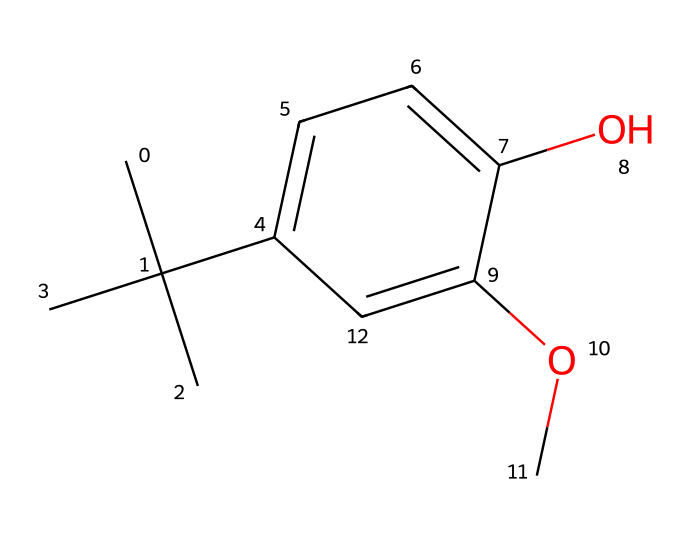What is the total number of carbon atoms in BHA? In the provided SMILES representation, count the 'C' symbols which correspond to carbon atoms. The chemical consists of a branched alkyl group (three carbon atoms) and a phenolic group (six carbon atoms), totaling nine carbon atoms.
Answer: nine How many oxygen atoms are present in BHA? The SMILES notation includes the symbol 'O' twice, indicating the presence of two oxygen atoms in the chemical structure of BHA.
Answer: two What functional groups are present in BHA? The structure contains a methoxy group (-OCH3) and a hydroxyl group (-OH). The methoxy group indicates the presence of ethers, and the hydroxyl group indicates the presence of alcohols.
Answer: methoxy, hydroxyl Is BHA considered a primary, secondary, or tertiary alcohol? The hydroxyl group (-OH) is attached to a carbon that is bonded to two other carbon atoms in the molecular structure, which characterizes it as a secondary alcohol.
Answer: secondary What type of chemical is BHA classified as? BHA is classified as a phenolic antioxidant due to the presence of the phenolic hydroxyl group that provides antioxidant properties which are key in food preservation.
Answer: phenolic antioxidant What does BHA primarily do in dry pet foods? BHA acts as an antioxidant, which means it helps to prevent the oxidation of fats and oils in pet food, thereby preserving freshness and preventing rancidity.
Answer: antioxidant How many rings are in the BHA structure? The structure features a single aromatic ring (the benzene part), which is made up of six carbon atoms in a cyclic arrangement, confirming one ring in the compound.
Answer: one 